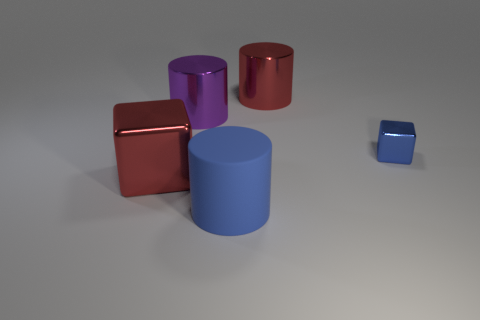Add 1 big metal cylinders. How many objects exist? 6 Subtract all cylinders. How many objects are left? 2 Subtract all tiny blue metallic things. Subtract all blue metal things. How many objects are left? 3 Add 1 blue things. How many blue things are left? 3 Add 3 shiny cylinders. How many shiny cylinders exist? 5 Subtract 0 gray blocks. How many objects are left? 5 